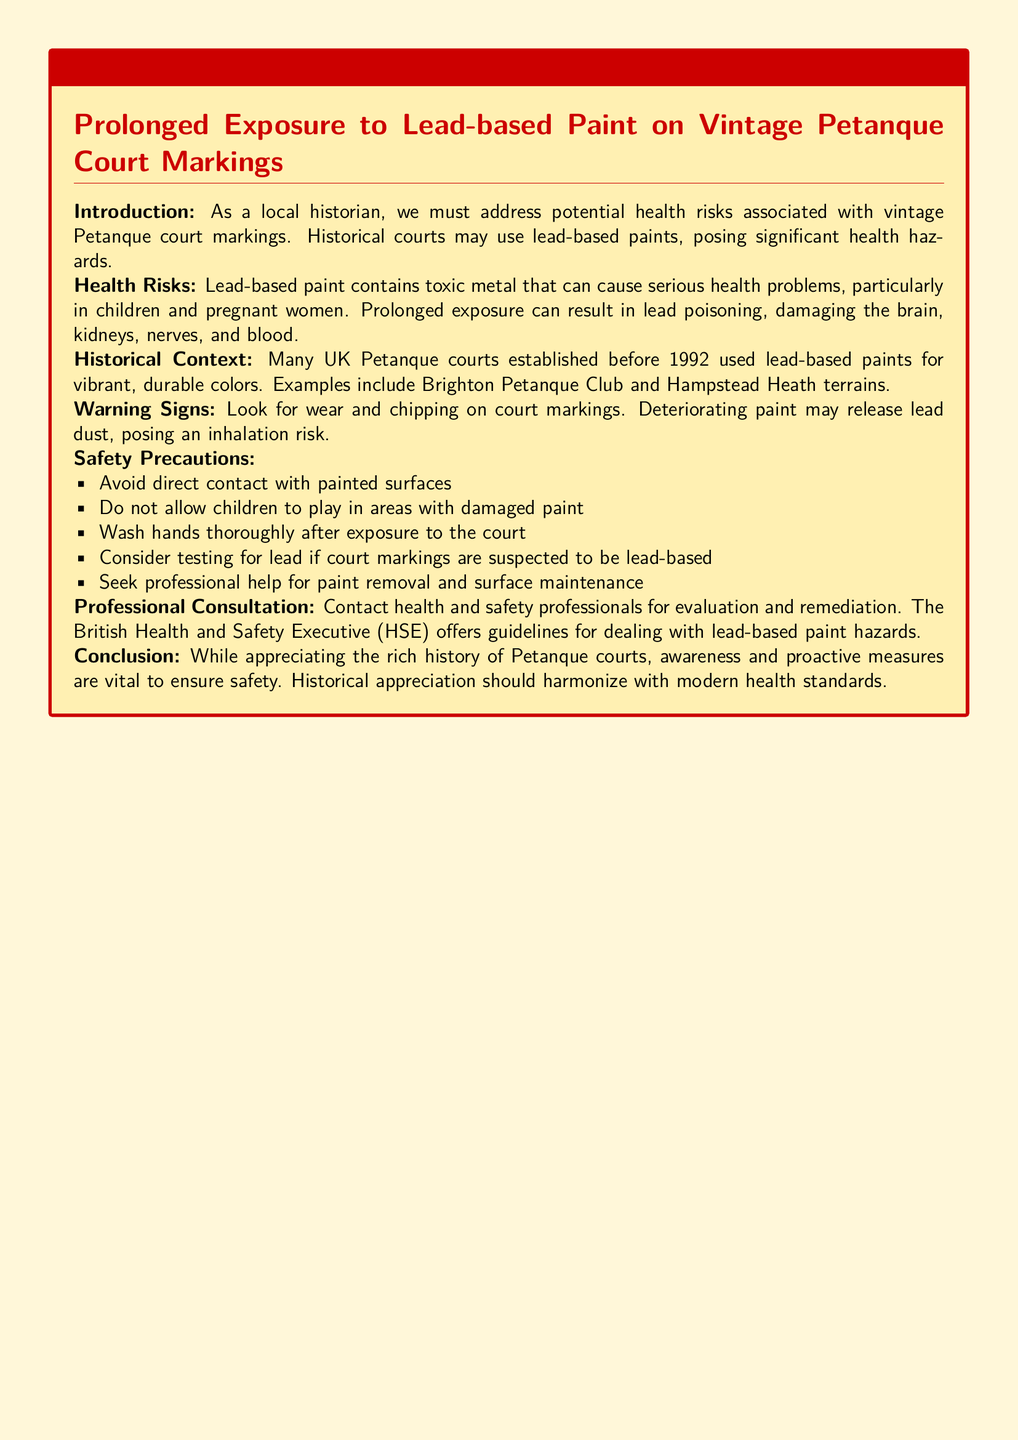What is the risk associated with lead-based paint? The document states that lead-based paint contains toxic metal that can cause serious health problems, particularly in children and pregnant women.
Answer: Serious health problems What established year did many UK Petanque courts use lead-based paints? The document mentions that many UK Petanque courts established before a specific year used lead-based paints for vibrant, durable colors.
Answer: 1992 What should you do after exposure to the court? The document advises washing hands thoroughly after exposure to the court.
Answer: Wash hands What are the main health effects of prolonged exposure to lead? The document lists that lead poisoning can damage the brain, kidneys, nerves, and blood due to prolonged exposure.
Answer: Brain, kidneys, nerves, blood What should be checked for warning signs? The document refers to looking for wear and chipping on court markings as warning signs.
Answer: Wear and chipping Who offers guidelines for dealing with lead-based paint hazards? The document mentions the British Health and Safety Executive (HSE) as the organization that offers guidelines.
Answer: British Health and Safety Executive (HSE) What should not be allowed in areas with damaged paint? The document explicitly states that children should not be allowed to play in areas with damaged paint.
Answer: Children What is the tone of the conclusion regarding historical appreciation and safety? The tone of the conclusion highlights the importance of harmonizing historical appreciation with modern health standards.
Answer: Harmonize with modern health standards 